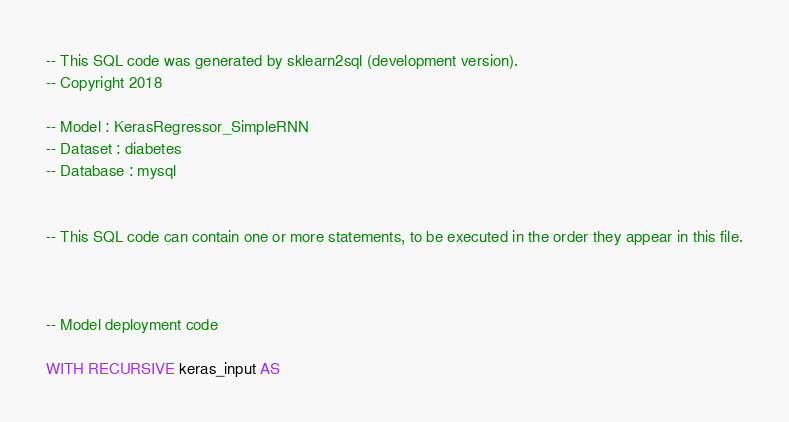Convert code to text. <code><loc_0><loc_0><loc_500><loc_500><_SQL_>-- This SQL code was generated by sklearn2sql (development version).
-- Copyright 2018

-- Model : KerasRegressor_SimpleRNN
-- Dataset : diabetes
-- Database : mysql


-- This SQL code can contain one or more statements, to be executed in the order they appear in this file.



-- Model deployment code

WITH RECURSIVE keras_input AS </code> 